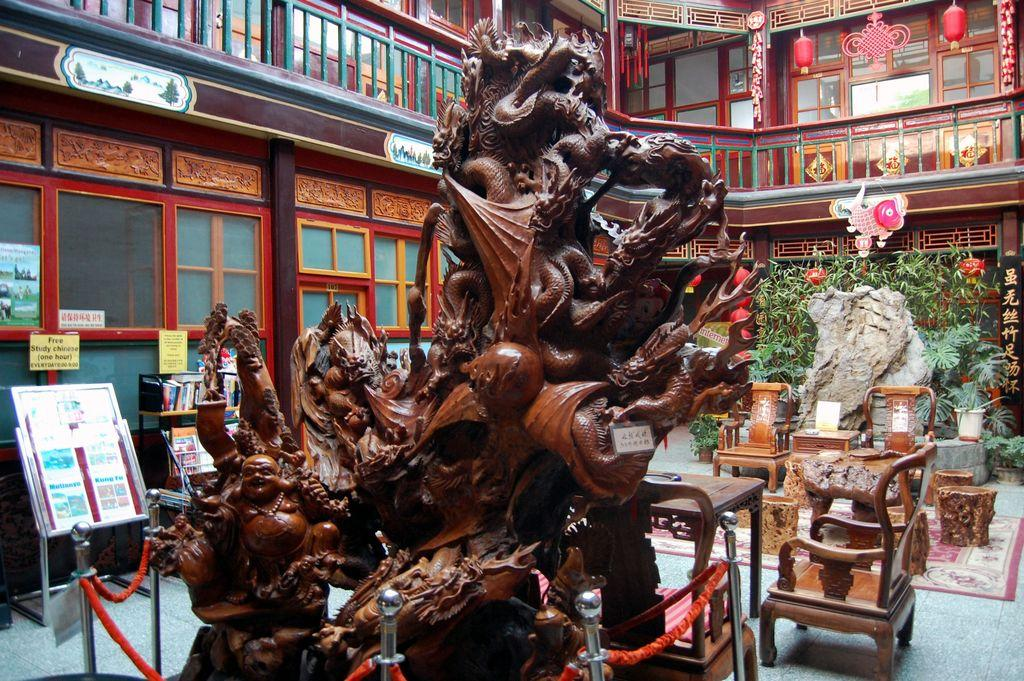What is the main subject in the image? There is a statue in the image. What objects are present near the statue? There are chairs in the image. What can be seen in the background of the image? There is a building in the background of the image. What type of liquid is being poured from the statue in the image? There is no liquid being poured from the statue in the image; it is a solid structure. 